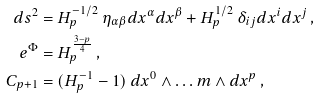<formula> <loc_0><loc_0><loc_500><loc_500>d s ^ { 2 } & = H _ { p } ^ { - 1 / 2 } \ \eta _ { \alpha \beta } d x ^ { \alpha } d x ^ { \beta } + H _ { p } ^ { 1 / 2 } \ \delta _ { i j } d x ^ { i } d x ^ { j } \, , \\ e ^ { \Phi } & = H _ { p } ^ { \frac { 3 - p } { 4 } } \, , \\ C _ { p + 1 } & = ( H _ { p } ^ { - 1 } - 1 ) \ d x ^ { 0 } \wedge \dots m \wedge d x ^ { p } \, ,</formula> 